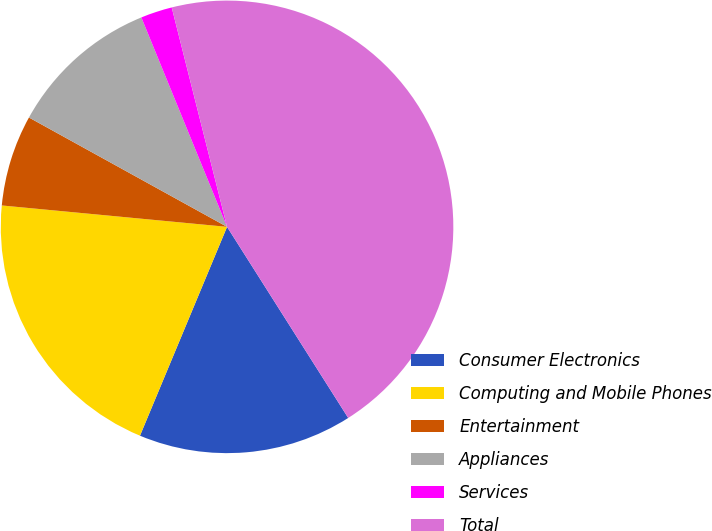Convert chart. <chart><loc_0><loc_0><loc_500><loc_500><pie_chart><fcel>Consumer Electronics<fcel>Computing and Mobile Phones<fcel>Entertainment<fcel>Appliances<fcel>Services<fcel>Total<nl><fcel>15.28%<fcel>20.22%<fcel>6.52%<fcel>10.79%<fcel>2.25%<fcel>44.94%<nl></chart> 